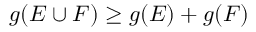<formula> <loc_0><loc_0><loc_500><loc_500>g ( E \cup F ) \geq g ( E ) + g ( F )</formula> 